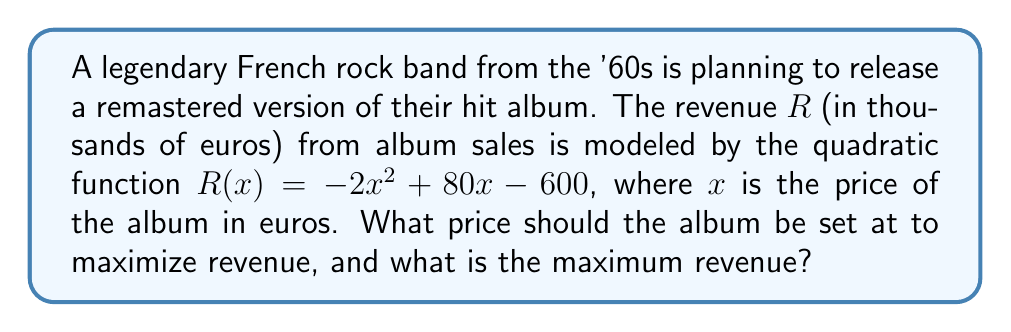Solve this math problem. To solve this problem, we'll follow these steps:

1) The revenue function is a quadratic function in the form $R(x) = -2x^2 + 80x - 600$.

2) To find the maximum revenue, we need to find the vertex of this parabola. The x-coordinate of the vertex will give us the optimal price, and the y-coordinate will give us the maximum revenue.

3) For a quadratic function in the form $ax^2 + bx + c$, the x-coordinate of the vertex is given by $x = -\frac{b}{2a}$.

4) In our case, $a = -2$ and $b = 80$. So:

   $x = -\frac{80}{2(-2)} = -\frac{80}{-4} = 20$

5) The optimal price is therefore 20 euros.

6) To find the maximum revenue, we substitute x = 20 into our original function:

   $R(20) = -2(20)^2 + 80(20) - 600$
          $= -2(400) + 1600 - 600$
          $= -800 + 1600 - 600$
          $= 200$

7) The maximum revenue is 200 thousand euros, or 200,000 euros.
Answer: Optimal price: €20; Maximum revenue: €200,000 